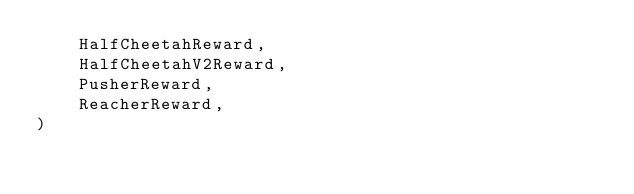<code> <loc_0><loc_0><loc_500><loc_500><_Python_>    HalfCheetahReward,
    HalfCheetahV2Reward,
    PusherReward,
    ReacherReward,
)
</code> 